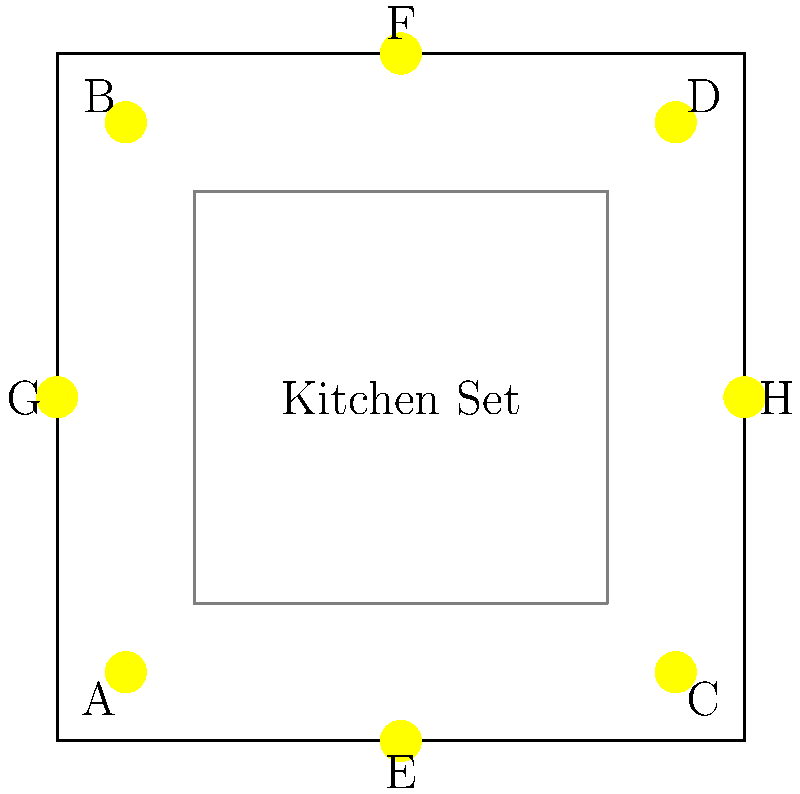In the given lighting setup for a cooking show, which combination of lights would provide the most efficient and balanced illumination for a chef working at the center of the kitchen set? Consider that we want to minimize shadows and ensure even lighting across the cooking area. To determine the most efficient and balanced lighting setup, we need to consider the following steps:

1. Analyze the light positions:
   - Lights A, B, C, and D are positioned at the corners of the studio.
   - Lights E, F, G, and H are positioned at the midpoints of each wall.

2. Consider the chef's position:
   - The chef is working at the center of the kitchen set.

3. Evaluate lighting angles:
   - Corner lights (A, B, C, D) provide angled lighting, which can create shadows.
   - Midpoint lights (E, F, G, H) provide more direct lighting from four sides.

4. Assess coverage:
   - Using only corner lights might leave the center underlit.
   - Using only midpoint lights provides even coverage from all sides.

5. Balance considerations:
   - A combination of corner and midpoint lights can provide depth and eliminate shadows.
   - However, using all lights might be excessive and create glare.

6. Optimal solution:
   - Use the four midpoint lights (E, F, G, H) as the primary light sources.
   - These lights will provide even illumination from all sides, minimizing shadows.

7. Fine-tuning:
   - If additional depth is needed, one or two corner lights could be added at lower intensity.
   - However, for the most efficient setup, the four midpoint lights are sufficient.

Therefore, the most efficient and balanced illumination would be achieved using lights E, F, G, and H.
Answer: Lights E, F, G, and H 